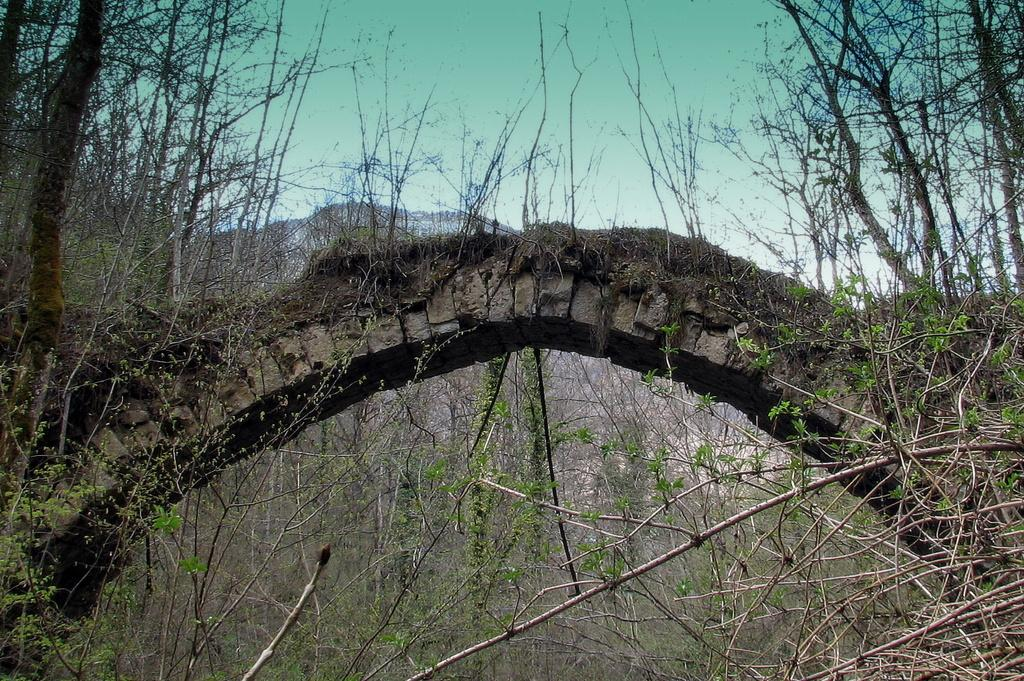What type of structure can be seen in the image? There is a bridge in the image. What other natural elements are present in the image? There are plants and trees in the image. What is the color of the sky in the image? The sky is blue in the image. What type of bird is flying over the bridge in the image? There are no birds visible in the image; it only features a bridge, plants, trees, and a blue sky. 